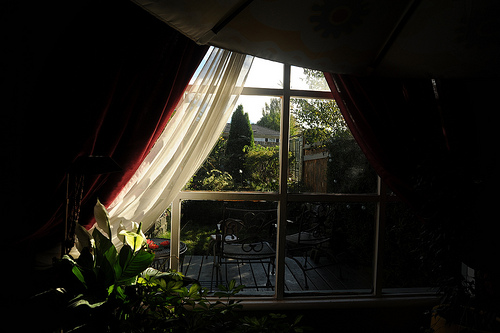<image>
Can you confirm if the iron chair is on the peace lily? No. The iron chair is not positioned on the peace lily. They may be near each other, but the iron chair is not supported by or resting on top of the peace lily. 